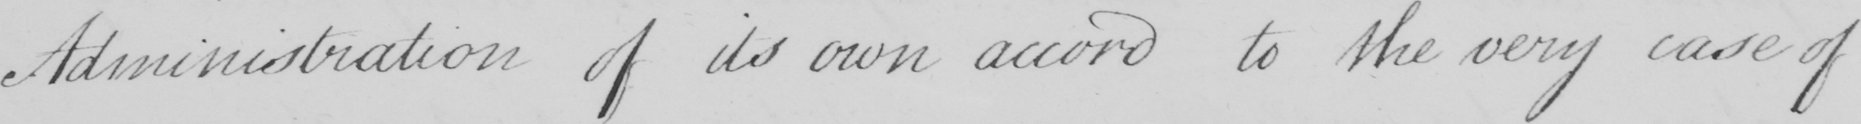Please provide the text content of this handwritten line. Administration of its own accord to the very case of 